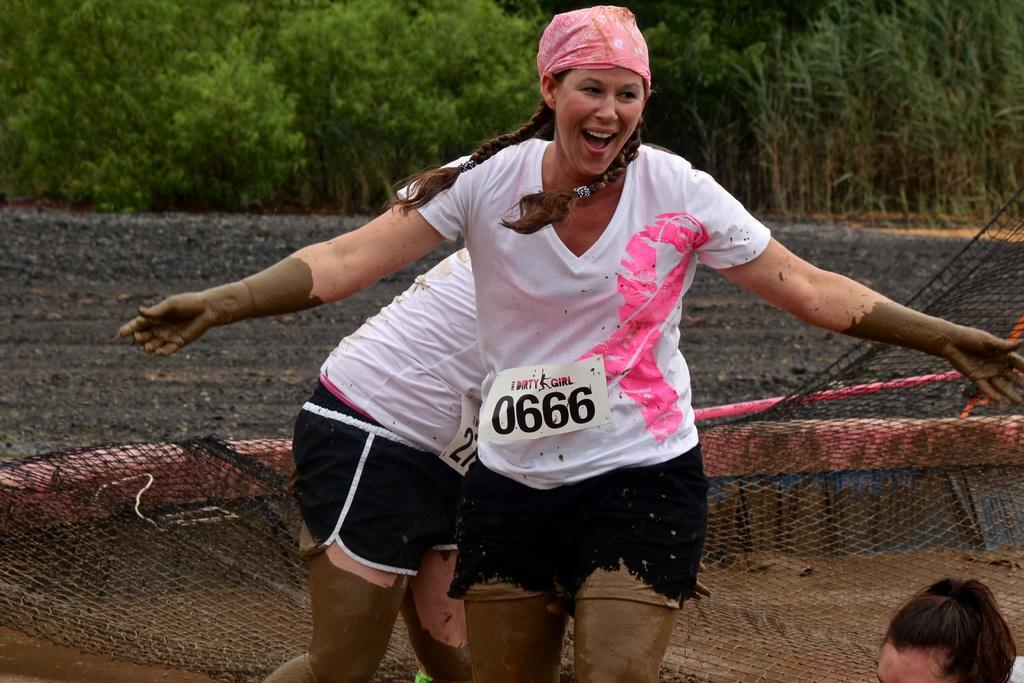<image>
Share a concise interpretation of the image provided. Two mud run competitors are labeled with numbers, one of them sporting 0666. 